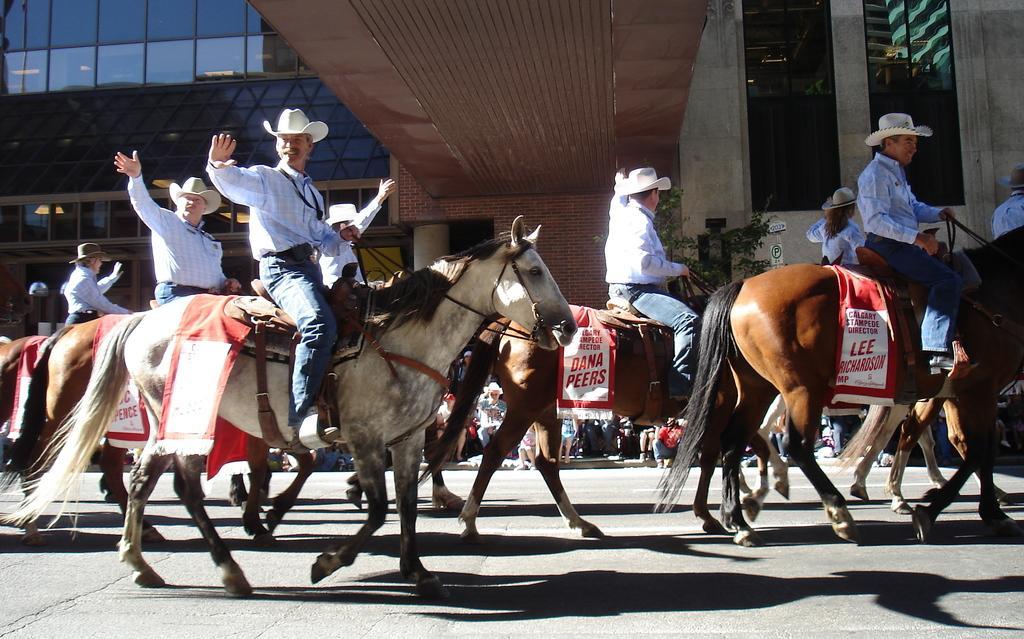In one or two sentences, can you explain what this image depicts? In the image we can see few persons were riding horse and they were wearing hat. In the background there is a building,glass,light,wall,tree and group of persons were sitting on the steps. 